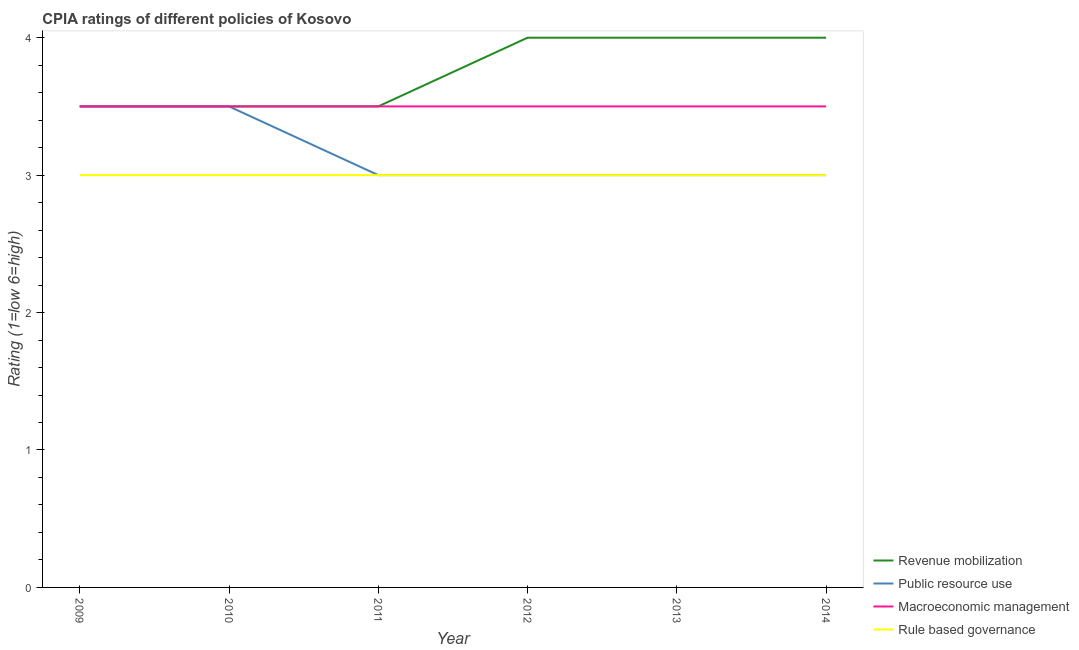Does the line corresponding to cpia rating of public resource use intersect with the line corresponding to cpia rating of macroeconomic management?
Your answer should be compact. Yes. Is the number of lines equal to the number of legend labels?
Your response must be concise. Yes. Across all years, what is the minimum cpia rating of rule based governance?
Your answer should be very brief. 3. What is the total cpia rating of rule based governance in the graph?
Offer a terse response. 18. What is the difference between the cpia rating of revenue mobilization in 2009 and that in 2012?
Your response must be concise. -0.5. What is the average cpia rating of macroeconomic management per year?
Provide a succinct answer. 3.5. Is the cpia rating of revenue mobilization in 2009 less than that in 2010?
Your answer should be compact. No. What is the difference between the highest and the second highest cpia rating of macroeconomic management?
Make the answer very short. 0. What is the difference between the highest and the lowest cpia rating of revenue mobilization?
Give a very brief answer. 0.5. In how many years, is the cpia rating of macroeconomic management greater than the average cpia rating of macroeconomic management taken over all years?
Your answer should be very brief. 0. Is it the case that in every year, the sum of the cpia rating of revenue mobilization and cpia rating of public resource use is greater than the cpia rating of macroeconomic management?
Offer a very short reply. Yes. Is the cpia rating of macroeconomic management strictly greater than the cpia rating of rule based governance over the years?
Provide a short and direct response. Yes. What is the difference between two consecutive major ticks on the Y-axis?
Offer a very short reply. 1. Are the values on the major ticks of Y-axis written in scientific E-notation?
Your response must be concise. No. Does the graph contain any zero values?
Your response must be concise. No. Where does the legend appear in the graph?
Give a very brief answer. Bottom right. How many legend labels are there?
Offer a very short reply. 4. What is the title of the graph?
Provide a short and direct response. CPIA ratings of different policies of Kosovo. Does "Overall level" appear as one of the legend labels in the graph?
Provide a short and direct response. No. What is the label or title of the X-axis?
Provide a succinct answer. Year. What is the label or title of the Y-axis?
Offer a very short reply. Rating (1=low 6=high). What is the Rating (1=low 6=high) of Public resource use in 2009?
Your answer should be compact. 3.5. What is the Rating (1=low 6=high) of Rule based governance in 2009?
Your response must be concise. 3. What is the Rating (1=low 6=high) in Revenue mobilization in 2010?
Your response must be concise. 3.5. What is the Rating (1=low 6=high) in Macroeconomic management in 2011?
Offer a terse response. 3.5. What is the Rating (1=low 6=high) of Revenue mobilization in 2012?
Offer a terse response. 4. What is the Rating (1=low 6=high) of Public resource use in 2012?
Make the answer very short. 3. What is the Rating (1=low 6=high) in Macroeconomic management in 2012?
Give a very brief answer. 3.5. What is the Rating (1=low 6=high) of Public resource use in 2013?
Offer a very short reply. 3. What is the Rating (1=low 6=high) in Macroeconomic management in 2013?
Offer a very short reply. 3.5. What is the Rating (1=low 6=high) in Rule based governance in 2013?
Provide a short and direct response. 3. What is the Rating (1=low 6=high) of Revenue mobilization in 2014?
Provide a succinct answer. 4. What is the Rating (1=low 6=high) in Public resource use in 2014?
Provide a short and direct response. 3. What is the Rating (1=low 6=high) in Rule based governance in 2014?
Your answer should be compact. 3. Across all years, what is the maximum Rating (1=low 6=high) of Public resource use?
Give a very brief answer. 3.5. Across all years, what is the minimum Rating (1=low 6=high) of Macroeconomic management?
Keep it short and to the point. 3.5. What is the total Rating (1=low 6=high) in Revenue mobilization in the graph?
Your answer should be very brief. 22.5. What is the total Rating (1=low 6=high) in Macroeconomic management in the graph?
Your response must be concise. 21. What is the difference between the Rating (1=low 6=high) of Revenue mobilization in 2009 and that in 2010?
Make the answer very short. 0. What is the difference between the Rating (1=low 6=high) of Public resource use in 2009 and that in 2010?
Provide a succinct answer. 0. What is the difference between the Rating (1=low 6=high) in Macroeconomic management in 2009 and that in 2010?
Provide a short and direct response. 0. What is the difference between the Rating (1=low 6=high) of Rule based governance in 2009 and that in 2010?
Your response must be concise. 0. What is the difference between the Rating (1=low 6=high) in Revenue mobilization in 2009 and that in 2011?
Offer a very short reply. 0. What is the difference between the Rating (1=low 6=high) of Public resource use in 2009 and that in 2011?
Offer a very short reply. 0.5. What is the difference between the Rating (1=low 6=high) of Public resource use in 2009 and that in 2012?
Provide a short and direct response. 0.5. What is the difference between the Rating (1=low 6=high) of Revenue mobilization in 2009 and that in 2013?
Your response must be concise. -0.5. What is the difference between the Rating (1=low 6=high) in Rule based governance in 2009 and that in 2013?
Keep it short and to the point. 0. What is the difference between the Rating (1=low 6=high) in Public resource use in 2009 and that in 2014?
Your answer should be very brief. 0.5. What is the difference between the Rating (1=low 6=high) of Rule based governance in 2009 and that in 2014?
Offer a terse response. 0. What is the difference between the Rating (1=low 6=high) of Revenue mobilization in 2010 and that in 2011?
Keep it short and to the point. 0. What is the difference between the Rating (1=low 6=high) in Revenue mobilization in 2010 and that in 2012?
Your answer should be compact. -0.5. What is the difference between the Rating (1=low 6=high) of Revenue mobilization in 2010 and that in 2013?
Provide a succinct answer. -0.5. What is the difference between the Rating (1=low 6=high) of Public resource use in 2010 and that in 2013?
Your response must be concise. 0.5. What is the difference between the Rating (1=low 6=high) of Macroeconomic management in 2010 and that in 2013?
Your response must be concise. 0. What is the difference between the Rating (1=low 6=high) in Rule based governance in 2010 and that in 2013?
Offer a very short reply. 0. What is the difference between the Rating (1=low 6=high) of Public resource use in 2010 and that in 2014?
Keep it short and to the point. 0.5. What is the difference between the Rating (1=low 6=high) in Rule based governance in 2010 and that in 2014?
Offer a terse response. 0. What is the difference between the Rating (1=low 6=high) in Public resource use in 2011 and that in 2012?
Offer a terse response. 0. What is the difference between the Rating (1=low 6=high) in Macroeconomic management in 2011 and that in 2012?
Provide a succinct answer. 0. What is the difference between the Rating (1=low 6=high) of Macroeconomic management in 2011 and that in 2013?
Provide a short and direct response. 0. What is the difference between the Rating (1=low 6=high) in Rule based governance in 2011 and that in 2013?
Your answer should be very brief. 0. What is the difference between the Rating (1=low 6=high) of Macroeconomic management in 2011 and that in 2014?
Your response must be concise. 0. What is the difference between the Rating (1=low 6=high) in Revenue mobilization in 2012 and that in 2013?
Offer a very short reply. 0. What is the difference between the Rating (1=low 6=high) in Rule based governance in 2012 and that in 2013?
Provide a succinct answer. 0. What is the difference between the Rating (1=low 6=high) of Rule based governance in 2013 and that in 2014?
Your answer should be compact. 0. What is the difference between the Rating (1=low 6=high) in Revenue mobilization in 2009 and the Rating (1=low 6=high) in Public resource use in 2010?
Your answer should be very brief. 0. What is the difference between the Rating (1=low 6=high) of Revenue mobilization in 2009 and the Rating (1=low 6=high) of Macroeconomic management in 2010?
Offer a terse response. 0. What is the difference between the Rating (1=low 6=high) of Revenue mobilization in 2009 and the Rating (1=low 6=high) of Public resource use in 2011?
Your answer should be very brief. 0.5. What is the difference between the Rating (1=low 6=high) in Revenue mobilization in 2009 and the Rating (1=low 6=high) in Public resource use in 2012?
Your answer should be very brief. 0.5. What is the difference between the Rating (1=low 6=high) of Revenue mobilization in 2009 and the Rating (1=low 6=high) of Macroeconomic management in 2012?
Offer a terse response. 0. What is the difference between the Rating (1=low 6=high) of Public resource use in 2009 and the Rating (1=low 6=high) of Macroeconomic management in 2012?
Your response must be concise. 0. What is the difference between the Rating (1=low 6=high) of Public resource use in 2009 and the Rating (1=low 6=high) of Rule based governance in 2012?
Your answer should be very brief. 0.5. What is the difference between the Rating (1=low 6=high) of Revenue mobilization in 2009 and the Rating (1=low 6=high) of Macroeconomic management in 2013?
Your answer should be compact. 0. What is the difference between the Rating (1=low 6=high) in Macroeconomic management in 2009 and the Rating (1=low 6=high) in Rule based governance in 2013?
Offer a very short reply. 0.5. What is the difference between the Rating (1=low 6=high) in Revenue mobilization in 2009 and the Rating (1=low 6=high) in Public resource use in 2014?
Keep it short and to the point. 0.5. What is the difference between the Rating (1=low 6=high) of Revenue mobilization in 2009 and the Rating (1=low 6=high) of Macroeconomic management in 2014?
Offer a very short reply. 0. What is the difference between the Rating (1=low 6=high) of Revenue mobilization in 2009 and the Rating (1=low 6=high) of Rule based governance in 2014?
Your answer should be very brief. 0.5. What is the difference between the Rating (1=low 6=high) in Macroeconomic management in 2009 and the Rating (1=low 6=high) in Rule based governance in 2014?
Offer a terse response. 0.5. What is the difference between the Rating (1=low 6=high) of Revenue mobilization in 2010 and the Rating (1=low 6=high) of Macroeconomic management in 2011?
Your answer should be compact. 0. What is the difference between the Rating (1=low 6=high) of Public resource use in 2010 and the Rating (1=low 6=high) of Macroeconomic management in 2011?
Offer a terse response. 0. What is the difference between the Rating (1=low 6=high) in Macroeconomic management in 2010 and the Rating (1=low 6=high) in Rule based governance in 2011?
Your answer should be compact. 0.5. What is the difference between the Rating (1=low 6=high) in Revenue mobilization in 2010 and the Rating (1=low 6=high) in Public resource use in 2012?
Keep it short and to the point. 0.5. What is the difference between the Rating (1=low 6=high) of Revenue mobilization in 2010 and the Rating (1=low 6=high) of Macroeconomic management in 2012?
Keep it short and to the point. 0. What is the difference between the Rating (1=low 6=high) of Revenue mobilization in 2010 and the Rating (1=low 6=high) of Rule based governance in 2012?
Your answer should be very brief. 0.5. What is the difference between the Rating (1=low 6=high) of Public resource use in 2010 and the Rating (1=low 6=high) of Macroeconomic management in 2012?
Offer a very short reply. 0. What is the difference between the Rating (1=low 6=high) in Macroeconomic management in 2010 and the Rating (1=low 6=high) in Rule based governance in 2012?
Provide a short and direct response. 0.5. What is the difference between the Rating (1=low 6=high) of Revenue mobilization in 2010 and the Rating (1=low 6=high) of Public resource use in 2013?
Your answer should be compact. 0.5. What is the difference between the Rating (1=low 6=high) in Revenue mobilization in 2010 and the Rating (1=low 6=high) in Rule based governance in 2013?
Provide a short and direct response. 0.5. What is the difference between the Rating (1=low 6=high) in Public resource use in 2010 and the Rating (1=low 6=high) in Macroeconomic management in 2013?
Your answer should be very brief. 0. What is the difference between the Rating (1=low 6=high) in Public resource use in 2010 and the Rating (1=low 6=high) in Rule based governance in 2013?
Make the answer very short. 0.5. What is the difference between the Rating (1=low 6=high) of Macroeconomic management in 2010 and the Rating (1=low 6=high) of Rule based governance in 2013?
Make the answer very short. 0.5. What is the difference between the Rating (1=low 6=high) of Revenue mobilization in 2010 and the Rating (1=low 6=high) of Public resource use in 2014?
Offer a terse response. 0.5. What is the difference between the Rating (1=low 6=high) of Revenue mobilization in 2010 and the Rating (1=low 6=high) of Macroeconomic management in 2014?
Make the answer very short. 0. What is the difference between the Rating (1=low 6=high) of Revenue mobilization in 2010 and the Rating (1=low 6=high) of Rule based governance in 2014?
Ensure brevity in your answer.  0.5. What is the difference between the Rating (1=low 6=high) in Public resource use in 2010 and the Rating (1=low 6=high) in Macroeconomic management in 2014?
Offer a terse response. 0. What is the difference between the Rating (1=low 6=high) in Public resource use in 2010 and the Rating (1=low 6=high) in Rule based governance in 2014?
Your answer should be very brief. 0.5. What is the difference between the Rating (1=low 6=high) in Revenue mobilization in 2011 and the Rating (1=low 6=high) in Macroeconomic management in 2012?
Offer a very short reply. 0. What is the difference between the Rating (1=low 6=high) of Revenue mobilization in 2011 and the Rating (1=low 6=high) of Rule based governance in 2012?
Give a very brief answer. 0.5. What is the difference between the Rating (1=low 6=high) of Public resource use in 2011 and the Rating (1=low 6=high) of Rule based governance in 2012?
Your response must be concise. 0. What is the difference between the Rating (1=low 6=high) of Revenue mobilization in 2011 and the Rating (1=low 6=high) of Public resource use in 2013?
Your answer should be very brief. 0.5. What is the difference between the Rating (1=low 6=high) in Public resource use in 2011 and the Rating (1=low 6=high) in Macroeconomic management in 2013?
Your response must be concise. -0.5. What is the difference between the Rating (1=low 6=high) in Revenue mobilization in 2011 and the Rating (1=low 6=high) in Macroeconomic management in 2014?
Ensure brevity in your answer.  0. What is the difference between the Rating (1=low 6=high) in Revenue mobilization in 2011 and the Rating (1=low 6=high) in Rule based governance in 2014?
Make the answer very short. 0.5. What is the difference between the Rating (1=low 6=high) of Public resource use in 2011 and the Rating (1=low 6=high) of Macroeconomic management in 2014?
Offer a very short reply. -0.5. What is the difference between the Rating (1=low 6=high) of Revenue mobilization in 2012 and the Rating (1=low 6=high) of Public resource use in 2013?
Provide a succinct answer. 1. What is the difference between the Rating (1=low 6=high) of Revenue mobilization in 2012 and the Rating (1=low 6=high) of Macroeconomic management in 2013?
Make the answer very short. 0.5. What is the difference between the Rating (1=low 6=high) in Revenue mobilization in 2012 and the Rating (1=low 6=high) in Rule based governance in 2013?
Offer a very short reply. 1. What is the difference between the Rating (1=low 6=high) in Macroeconomic management in 2012 and the Rating (1=low 6=high) in Rule based governance in 2013?
Provide a succinct answer. 0.5. What is the difference between the Rating (1=low 6=high) of Macroeconomic management in 2012 and the Rating (1=low 6=high) of Rule based governance in 2014?
Make the answer very short. 0.5. What is the difference between the Rating (1=low 6=high) of Revenue mobilization in 2013 and the Rating (1=low 6=high) of Macroeconomic management in 2014?
Your response must be concise. 0.5. What is the difference between the Rating (1=low 6=high) of Revenue mobilization in 2013 and the Rating (1=low 6=high) of Rule based governance in 2014?
Give a very brief answer. 1. What is the difference between the Rating (1=low 6=high) of Public resource use in 2013 and the Rating (1=low 6=high) of Macroeconomic management in 2014?
Make the answer very short. -0.5. What is the difference between the Rating (1=low 6=high) in Public resource use in 2013 and the Rating (1=low 6=high) in Rule based governance in 2014?
Offer a terse response. 0. What is the difference between the Rating (1=low 6=high) of Macroeconomic management in 2013 and the Rating (1=low 6=high) of Rule based governance in 2014?
Provide a short and direct response. 0.5. What is the average Rating (1=low 6=high) of Revenue mobilization per year?
Keep it short and to the point. 3.75. What is the average Rating (1=low 6=high) in Public resource use per year?
Offer a very short reply. 3.17. What is the average Rating (1=low 6=high) of Rule based governance per year?
Keep it short and to the point. 3. In the year 2009, what is the difference between the Rating (1=low 6=high) of Revenue mobilization and Rating (1=low 6=high) of Public resource use?
Provide a short and direct response. 0. In the year 2009, what is the difference between the Rating (1=low 6=high) in Revenue mobilization and Rating (1=low 6=high) in Macroeconomic management?
Offer a very short reply. 0. In the year 2009, what is the difference between the Rating (1=low 6=high) in Public resource use and Rating (1=low 6=high) in Macroeconomic management?
Your answer should be compact. 0. In the year 2010, what is the difference between the Rating (1=low 6=high) of Revenue mobilization and Rating (1=low 6=high) of Public resource use?
Your answer should be very brief. 0. In the year 2010, what is the difference between the Rating (1=low 6=high) of Revenue mobilization and Rating (1=low 6=high) of Macroeconomic management?
Offer a terse response. 0. In the year 2010, what is the difference between the Rating (1=low 6=high) in Public resource use and Rating (1=low 6=high) in Rule based governance?
Ensure brevity in your answer.  0.5. In the year 2010, what is the difference between the Rating (1=low 6=high) of Macroeconomic management and Rating (1=low 6=high) of Rule based governance?
Offer a terse response. 0.5. In the year 2011, what is the difference between the Rating (1=low 6=high) of Revenue mobilization and Rating (1=low 6=high) of Public resource use?
Offer a terse response. 0.5. In the year 2011, what is the difference between the Rating (1=low 6=high) in Revenue mobilization and Rating (1=low 6=high) in Macroeconomic management?
Offer a very short reply. 0. In the year 2011, what is the difference between the Rating (1=low 6=high) of Public resource use and Rating (1=low 6=high) of Macroeconomic management?
Give a very brief answer. -0.5. In the year 2011, what is the difference between the Rating (1=low 6=high) of Public resource use and Rating (1=low 6=high) of Rule based governance?
Provide a short and direct response. 0. In the year 2011, what is the difference between the Rating (1=low 6=high) of Macroeconomic management and Rating (1=low 6=high) of Rule based governance?
Make the answer very short. 0.5. In the year 2012, what is the difference between the Rating (1=low 6=high) in Revenue mobilization and Rating (1=low 6=high) in Macroeconomic management?
Your response must be concise. 0.5. In the year 2012, what is the difference between the Rating (1=low 6=high) in Public resource use and Rating (1=low 6=high) in Rule based governance?
Your answer should be very brief. 0. In the year 2013, what is the difference between the Rating (1=low 6=high) in Revenue mobilization and Rating (1=low 6=high) in Rule based governance?
Your answer should be very brief. 1. In the year 2013, what is the difference between the Rating (1=low 6=high) in Public resource use and Rating (1=low 6=high) in Macroeconomic management?
Your response must be concise. -0.5. In the year 2014, what is the difference between the Rating (1=low 6=high) of Revenue mobilization and Rating (1=low 6=high) of Rule based governance?
Give a very brief answer. 1. In the year 2014, what is the difference between the Rating (1=low 6=high) of Public resource use and Rating (1=low 6=high) of Macroeconomic management?
Your response must be concise. -0.5. In the year 2014, what is the difference between the Rating (1=low 6=high) of Public resource use and Rating (1=low 6=high) of Rule based governance?
Provide a succinct answer. 0. In the year 2014, what is the difference between the Rating (1=low 6=high) of Macroeconomic management and Rating (1=low 6=high) of Rule based governance?
Keep it short and to the point. 0.5. What is the ratio of the Rating (1=low 6=high) in Rule based governance in 2009 to that in 2010?
Provide a short and direct response. 1. What is the ratio of the Rating (1=low 6=high) of Revenue mobilization in 2009 to that in 2012?
Your answer should be compact. 0.88. What is the ratio of the Rating (1=low 6=high) of Rule based governance in 2009 to that in 2012?
Give a very brief answer. 1. What is the ratio of the Rating (1=low 6=high) in Macroeconomic management in 2009 to that in 2013?
Keep it short and to the point. 1. What is the ratio of the Rating (1=low 6=high) of Rule based governance in 2009 to that in 2014?
Offer a terse response. 1. What is the ratio of the Rating (1=low 6=high) in Public resource use in 2010 to that in 2011?
Your answer should be compact. 1.17. What is the ratio of the Rating (1=low 6=high) in Revenue mobilization in 2010 to that in 2012?
Offer a terse response. 0.88. What is the ratio of the Rating (1=low 6=high) of Public resource use in 2010 to that in 2012?
Give a very brief answer. 1.17. What is the ratio of the Rating (1=low 6=high) of Macroeconomic management in 2010 to that in 2013?
Your response must be concise. 1. What is the ratio of the Rating (1=low 6=high) in Revenue mobilization in 2010 to that in 2014?
Give a very brief answer. 0.88. What is the ratio of the Rating (1=low 6=high) of Public resource use in 2010 to that in 2014?
Give a very brief answer. 1.17. What is the ratio of the Rating (1=low 6=high) in Rule based governance in 2010 to that in 2014?
Offer a terse response. 1. What is the ratio of the Rating (1=low 6=high) of Public resource use in 2011 to that in 2012?
Give a very brief answer. 1. What is the ratio of the Rating (1=low 6=high) of Rule based governance in 2011 to that in 2012?
Make the answer very short. 1. What is the ratio of the Rating (1=low 6=high) of Revenue mobilization in 2011 to that in 2013?
Your answer should be very brief. 0.88. What is the ratio of the Rating (1=low 6=high) in Macroeconomic management in 2011 to that in 2013?
Provide a succinct answer. 1. What is the ratio of the Rating (1=low 6=high) in Revenue mobilization in 2011 to that in 2014?
Make the answer very short. 0.88. What is the ratio of the Rating (1=low 6=high) in Public resource use in 2011 to that in 2014?
Give a very brief answer. 1. What is the ratio of the Rating (1=low 6=high) in Public resource use in 2012 to that in 2013?
Keep it short and to the point. 1. What is the ratio of the Rating (1=low 6=high) in Rule based governance in 2012 to that in 2014?
Ensure brevity in your answer.  1. What is the ratio of the Rating (1=low 6=high) of Revenue mobilization in 2013 to that in 2014?
Offer a very short reply. 1. What is the ratio of the Rating (1=low 6=high) in Public resource use in 2013 to that in 2014?
Provide a succinct answer. 1. What is the ratio of the Rating (1=low 6=high) in Rule based governance in 2013 to that in 2014?
Provide a succinct answer. 1. What is the difference between the highest and the second highest Rating (1=low 6=high) of Revenue mobilization?
Make the answer very short. 0. What is the difference between the highest and the second highest Rating (1=low 6=high) in Public resource use?
Provide a succinct answer. 0. What is the difference between the highest and the second highest Rating (1=low 6=high) in Macroeconomic management?
Ensure brevity in your answer.  0. What is the difference between the highest and the second highest Rating (1=low 6=high) in Rule based governance?
Your answer should be very brief. 0. What is the difference between the highest and the lowest Rating (1=low 6=high) in Rule based governance?
Provide a short and direct response. 0. 